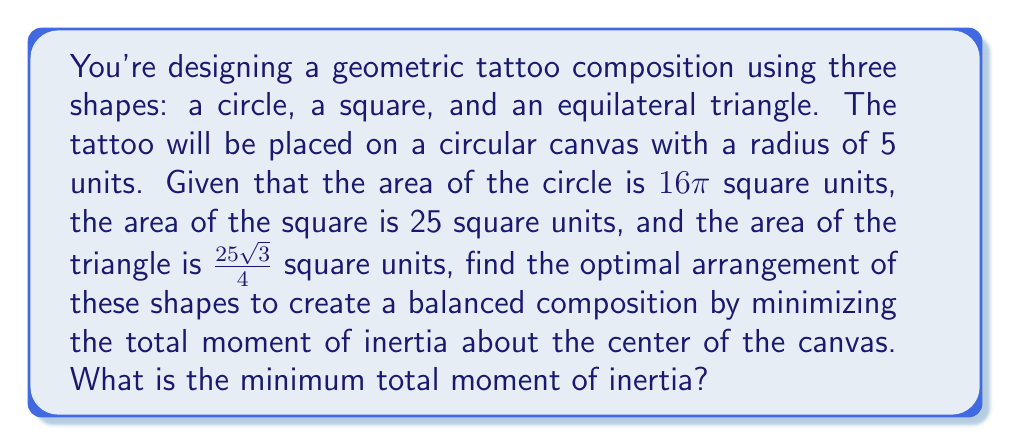Can you answer this question? To solve this problem, we'll follow these steps:

1) First, recall that the moment of inertia (I) for a shape about a point is given by:
   $I = mr^2$
   where m is the mass (in this case, we'll use area as a proxy for mass) and r is the distance from the center of mass of the shape to the point of rotation.

2) We need to find the radii of each shape:
   Circle: $A = \pi r^2$, so $16\pi = \pi r^2$, thus $r_c = 4$ units
   Square: $A = s^2$, so $25 = s^2$, thus $s = 5$ units, and $r_s = \frac{5\sqrt{2}}{2}$ units (half-diagonal)
   Triangle: $A = \frac{\sqrt{3}}{4}a^2$, so $\frac{25\sqrt{3}}{4} = \frac{\sqrt{3}}{4}a^2$, thus $a = 5$ units, and $r_t = \frac{5\sqrt{3}}{3}$ units (distance from center to vertex)

3) The optimal arrangement will place the centers of mass of each shape equidistant from the center of the canvas, forming an equilateral triangle. Let's call this distance x.

4) The total moment of inertia will be:
   $I_{total} = 16\pi x^2 + 25x^2 + \frac{25\sqrt{3}}{4}x^2$

5) We need to ensure that the shapes don't overlap and fit within the canvas. The constraint is:
   $x + \max(r_c, r_s, r_t) \leq 5$

6) The maximum radius is $r_s = \frac{5\sqrt{2}}{2} \approx 3.54$ units. So our constraint is:
   $x + \frac{5\sqrt{2}}{2} \leq 5$
   $x \leq 5 - \frac{5\sqrt{2}}{2} \approx 1.46$ units

7) The minimum moment of inertia will occur at the maximum allowed x. So:
   $x = 5 - \frac{5\sqrt{2}}{2}$

8) Substituting this into our total moment of inertia equation:
   $I_{total} = (16\pi + 25 + \frac{25\sqrt{3}}{4})(5 - \frac{5\sqrt{2}}{2})^2$

9) Simplifying:
   $I_{total} = (50\pi + 25 + \frac{25\sqrt{3}}{4})(5 - \frac{5\sqrt{2}}{2})^2$
   $\approx 218.47$ square units
Answer: $I_{min} = (50\pi + 25 + \frac{25\sqrt{3}}{4})(5 - \frac{5\sqrt{2}}{2})^2$ square units 